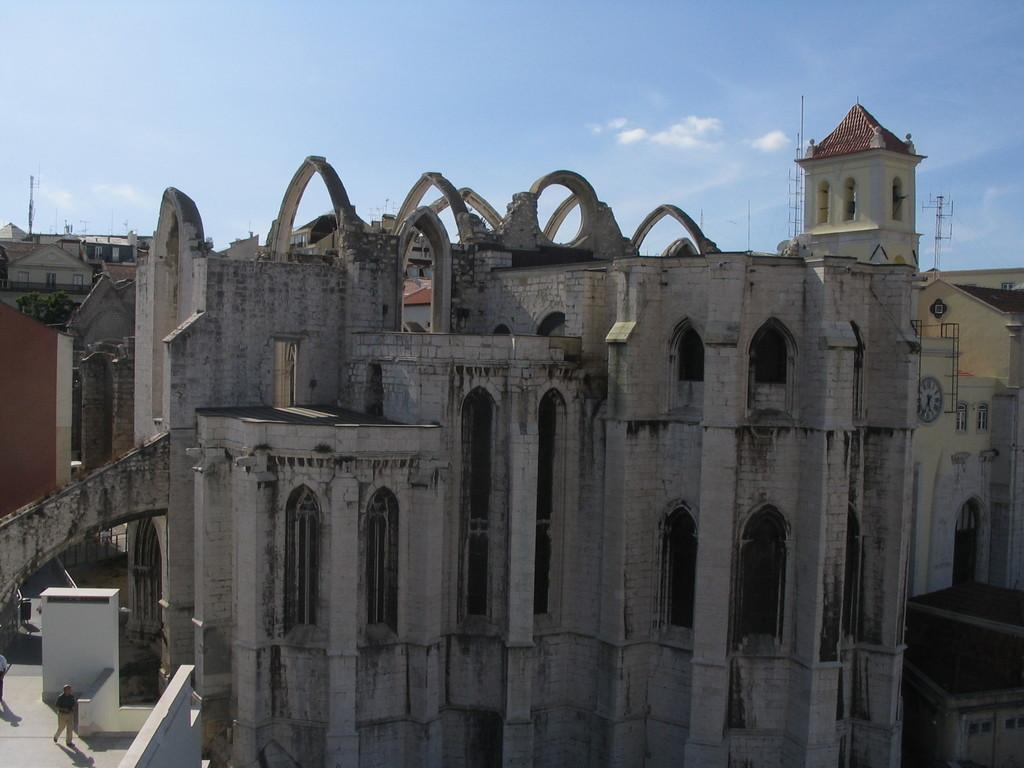What type of structures are visible in the image in the image? There is a group of buildings in the image. Can you describe any specific features of the buildings? Unfortunately, the provided facts do not mention any specific features of the buildings. What else can be seen on the buildings in the image? There is a clock on a wall in the image. How many people are visible in the image? There are two people on the road in the image. What else can be seen in the image besides the buildings and people? There are poles in the image. What is the weather like in the image? The sky is visible in the image and appears cloudy. How many trees are visible in the image? There is no mention of trees in the provided facts, so we cannot determine the number of trees in the image. What is the size of the brain visible in the image? There is no brain present in the image, so we cannot determine its size. 